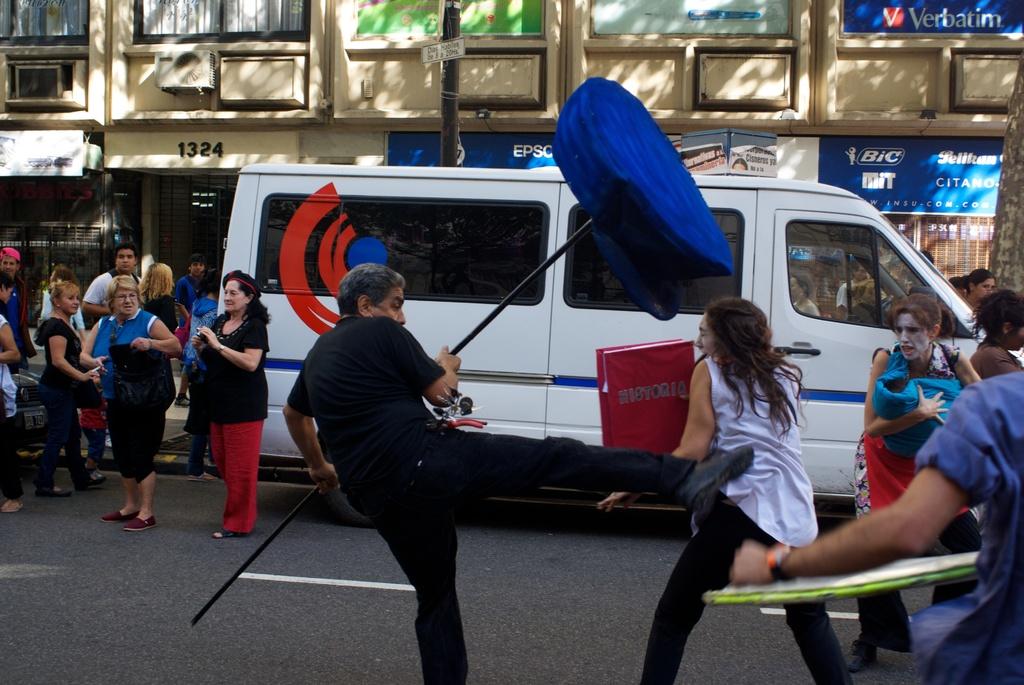What is the building number?
Provide a succinct answer. 1324. What company is on the blue banner at the top right of the pic?
Ensure brevity in your answer.  Verbatim. 